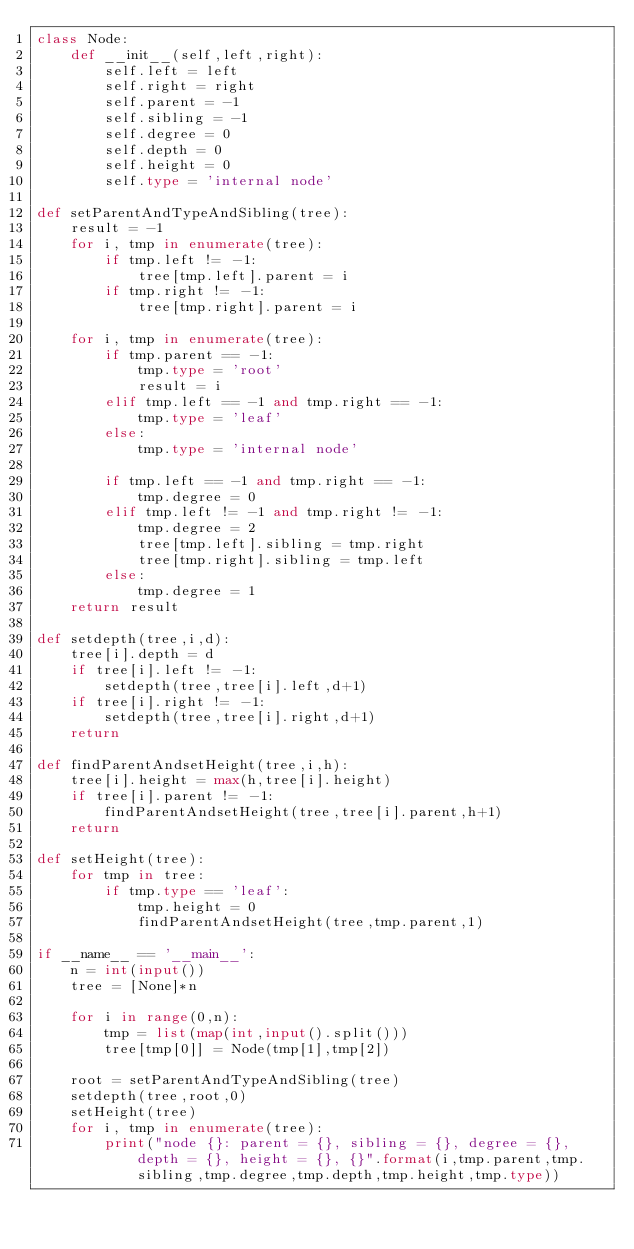Convert code to text. <code><loc_0><loc_0><loc_500><loc_500><_Python_>class Node:
    def __init__(self,left,right):
        self.left = left
        self.right = right
        self.parent = -1
        self.sibling = -1
        self.degree = 0
        self.depth = 0
        self.height = 0
        self.type = 'internal node'

def setParentAndTypeAndSibling(tree):
    result = -1
    for i, tmp in enumerate(tree):
        if tmp.left != -1:
            tree[tmp.left].parent = i
        if tmp.right != -1:
            tree[tmp.right].parent = i

    for i, tmp in enumerate(tree):
        if tmp.parent == -1:
            tmp.type = 'root'
            result = i
        elif tmp.left == -1 and tmp.right == -1:
            tmp.type = 'leaf'
        else:
            tmp.type = 'internal node'

        if tmp.left == -1 and tmp.right == -1:
            tmp.degree = 0
        elif tmp.left != -1 and tmp.right != -1:
            tmp.degree = 2
            tree[tmp.left].sibling = tmp.right
            tree[tmp.right].sibling = tmp.left
        else:
            tmp.degree = 1
    return result

def setdepth(tree,i,d):
    tree[i].depth = d
    if tree[i].left != -1:
        setdepth(tree,tree[i].left,d+1)
    if tree[i].right != -1:
        setdepth(tree,tree[i].right,d+1)
    return

def findParentAndsetHeight(tree,i,h):
    tree[i].height = max(h,tree[i].height)
    if tree[i].parent != -1:
        findParentAndsetHeight(tree,tree[i].parent,h+1)
    return

def setHeight(tree):
    for tmp in tree:
        if tmp.type == 'leaf':
            tmp.height = 0
            findParentAndsetHeight(tree,tmp.parent,1)

if __name__ == '__main__':
    n = int(input())
    tree = [None]*n

    for i in range(0,n):
        tmp = list(map(int,input().split()))
        tree[tmp[0]] = Node(tmp[1],tmp[2])
    
    root = setParentAndTypeAndSibling(tree)
    setdepth(tree,root,0)
    setHeight(tree)
    for i, tmp in enumerate(tree):
        print("node {}: parent = {}, sibling = {}, degree = {}, depth = {}, height = {}, {}".format(i,tmp.parent,tmp.sibling,tmp.degree,tmp.depth,tmp.height,tmp.type))</code> 